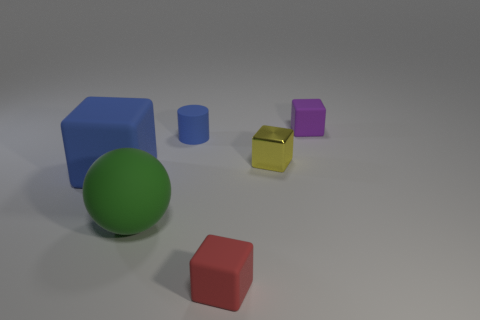Subtract all tiny purple cubes. How many cubes are left? 3 Subtract all brown cubes. Subtract all gray spheres. How many cubes are left? 4 Add 2 tiny blue rubber cylinders. How many objects exist? 8 Subtract all balls. How many objects are left? 5 Subtract all tiny purple rubber objects. Subtract all big rubber balls. How many objects are left? 4 Add 2 tiny blue objects. How many tiny blue objects are left? 3 Add 5 large things. How many large things exist? 7 Subtract 0 gray blocks. How many objects are left? 6 